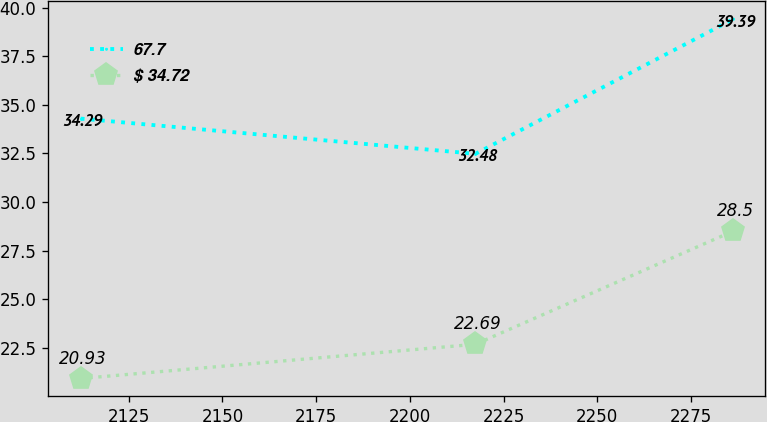Convert chart to OTSL. <chart><loc_0><loc_0><loc_500><loc_500><line_chart><ecel><fcel>67.7<fcel>$ 34.72<nl><fcel>2112.17<fcel>34.29<fcel>20.93<nl><fcel>2217.5<fcel>32.48<fcel>22.69<nl><fcel>2286.19<fcel>39.39<fcel>28.5<nl></chart> 